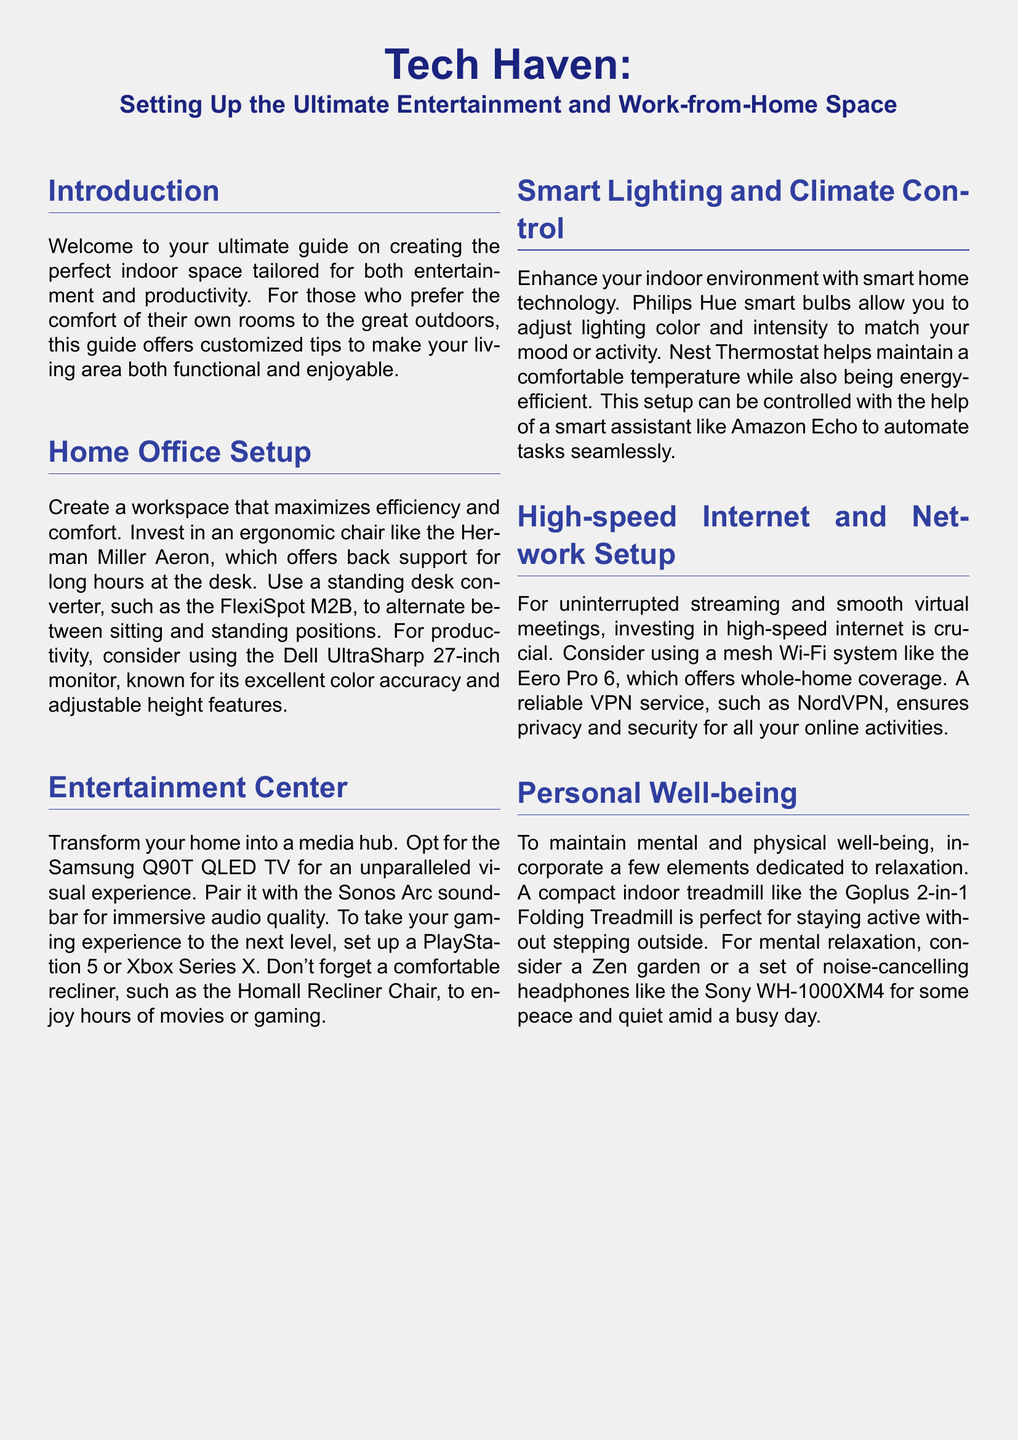What is the recommended ergonomic chair? The document suggests the Herman Miller Aeron as the recommended ergonomic chair for long hours at the desk.
Answer: Herman Miller Aeron What is mentioned as a good monitor for productivity? The Dell UltraSharp 27-inch monitor is highlighted for its excellent color accuracy and adjustable height features, making it suitable for productivity.
Answer: Dell UltraSharp 27-inch Which TV is suggested for an unparalleled visual experience? According to the document, the Samsung Q90T QLED TV is recommended for an unparalleled visual experience in a home entertainment setup.
Answer: Samsung Q90T QLED TV What smart bulbs are recommended for adjusting lighting? The document states that Philips Hue smart bulbs are recommended for adjusting lighting color and intensity to match your mood or activity.
Answer: Philips Hue What treadmill is suggested for indoor activity? The document advises using the Goplus 2-in-1 Folding Treadmill as a compact option for staying active indoors without stepping outside.
Answer: Goplus 2-in-1 Folding Treadmill What technology helps maintain a comfortable temperature? The Nest Thermostat is mentioned in the document as a technology that helps maintain a comfortable temperature while also being energy-efficient.
Answer: Nest Thermostat Which soundbar is paired with the Samsung Q90T? The Sonos Arc soundbar is recommended in combination with the Samsung Q90T QLED TV for immersive audio quality.
Answer: Sonos Arc What type of headphones are suggested for mental relaxation? The document recommends noise-cancelling headphones like the Sony WH-1000XM4 for peace and quiet amid a busy day.
Answer: Sony WH-1000XM4 How many sections are there in the document? The document contains five main sections: Home Office Setup, Entertainment Center, Smart Lighting and Climate Control, High-speed Internet and Network Setup, and Personal Well-being.
Answer: Five 